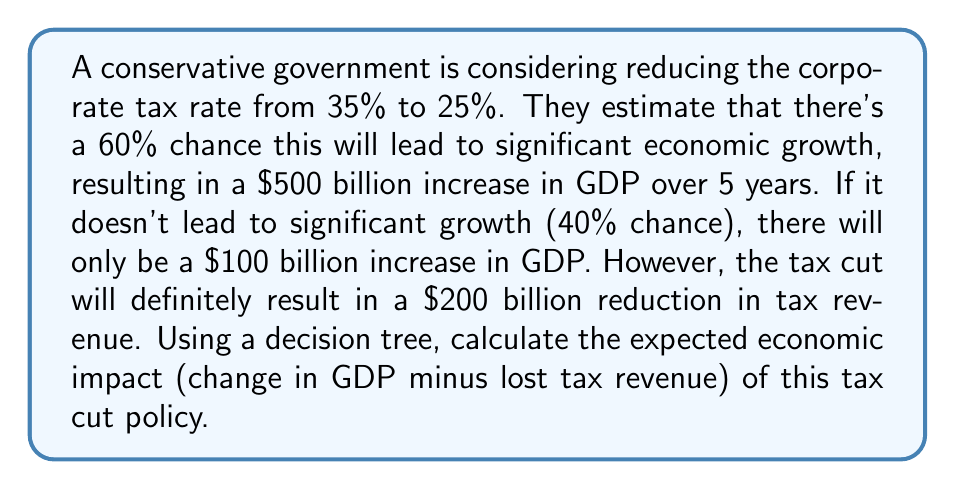Solve this math problem. Let's approach this problem using a decision tree:

1. First, we'll set up our decision tree:

[asy]
import geometry;

pair A=(0,0), B=(100,50), C=(100,-50);
draw(A--B--C--cycle);
label("Tax Cut",A,W);
label("Growth (60%)",B,E);
label("No Growth (40%)",C,E);

pair D=(200,50), E=(200,-50);
draw(B--D);
draw(C--E);
label("$500B GDP increase",D,E);
label("$100B GDP increase",E,E);
[/asy]

2. Now, let's calculate the expected value (EV) of each outcome:

   a. Growth scenario:
      Probability = 60% = 0.6
      GDP increase = $500 billion
      EV(Growth) = 0.6 × $500 billion = $300 billion

   b. No Growth scenario:
      Probability = 40% = 0.4
      GDP increase = $100 billion
      EV(No Growth) = 0.4 × $100 billion = $40 billion

3. The total expected GDP increase is:
   $$\text{E}(\text{GDP increase}) = \text{EV(Growth)} + \text{EV(No Growth)}$$
   $$\text{E}(\text{GDP increase}) = $300 \text{ billion} + $40 \text{ billion} = $340 \text{ billion}$$

4. However, we need to subtract the certain loss in tax revenue:
   $$\text{Net Economic Impact} = \text{E}(\text{GDP increase}) - \text{Tax Revenue Loss}$$
   $$\text{Net Economic Impact} = $340 \text{ billion} - $200 \text{ billion} = $140 \text{ billion}$$

Therefore, the expected economic impact of the tax cut policy is a net positive of $140 billion over 5 years.
Answer: $140 billion 